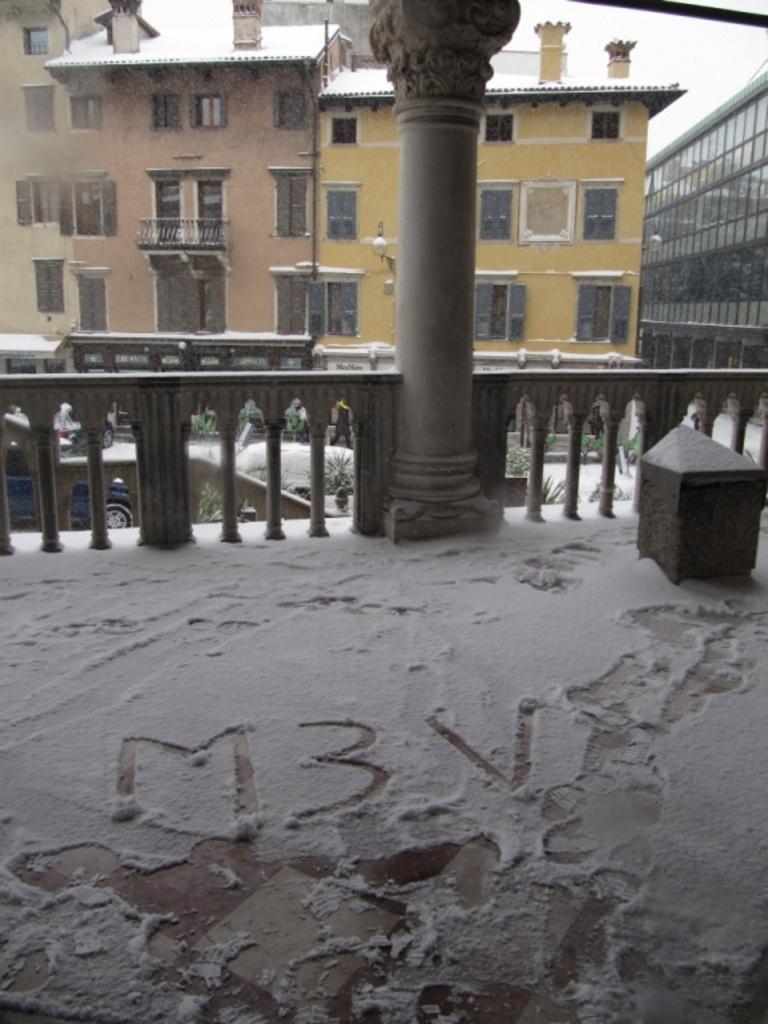Please provide a concise description of this image. In the foreground of the picture there is snow. In the center of the picture there is railing. In the background there are buildings, windows and doors. In the center of the picture there are vehicle, plants and snow. 